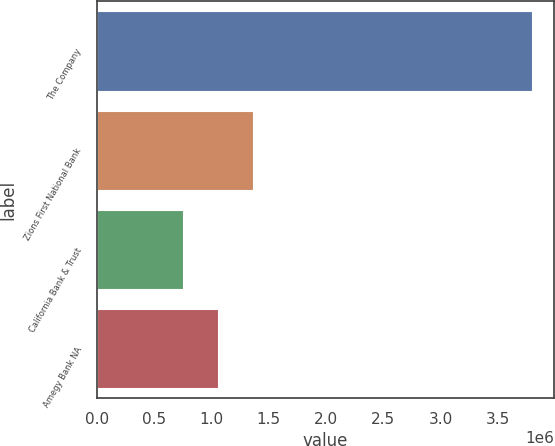Convert chart to OTSL. <chart><loc_0><loc_0><loc_500><loc_500><bar_chart><fcel>The Company<fcel>Zions First National Bank<fcel>California Bank & Trust<fcel>Amegy Bank NA<nl><fcel>3.80126e+06<fcel>1.36205e+06<fcel>752253<fcel>1.05715e+06<nl></chart> 